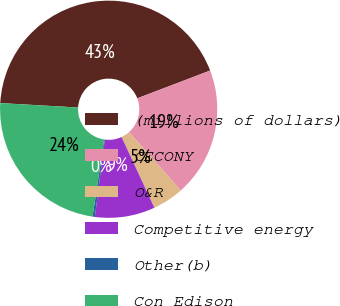Convert chart. <chart><loc_0><loc_0><loc_500><loc_500><pie_chart><fcel>(millions of dollars)<fcel>CECONY<fcel>O&R<fcel>Competitive energy<fcel>Other(b)<fcel>Con Edison<nl><fcel>43.3%<fcel>19.24%<fcel>4.64%<fcel>8.94%<fcel>0.34%<fcel>23.53%<nl></chart> 